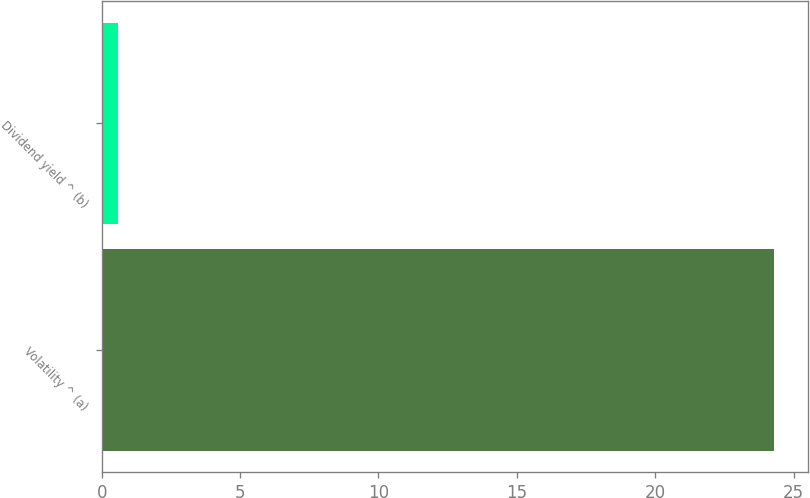Convert chart. <chart><loc_0><loc_0><loc_500><loc_500><bar_chart><fcel>Volatility ^ (a)<fcel>Dividend yield ^ (b)<nl><fcel>24.3<fcel>0.6<nl></chart> 